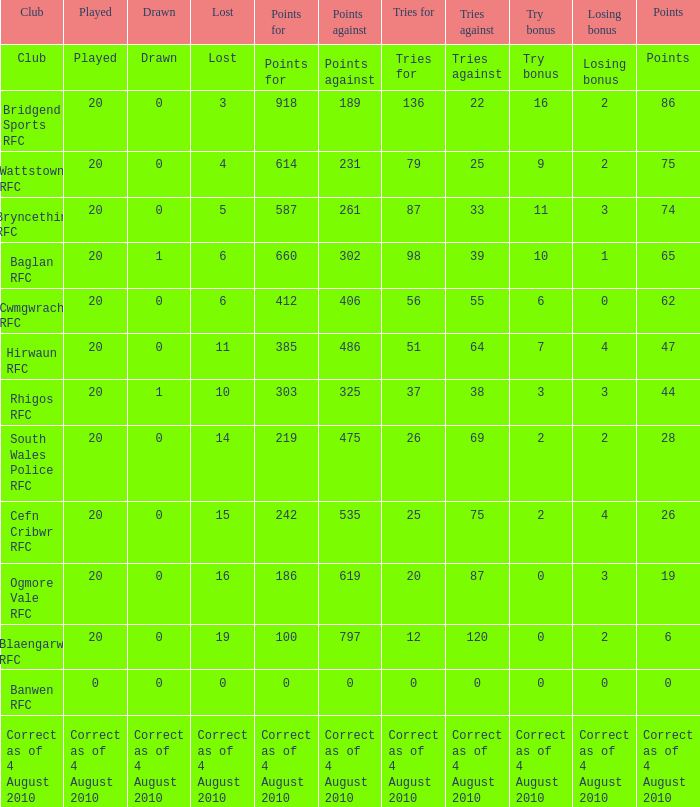Would you be able to parse every entry in this table? {'header': ['Club', 'Played', 'Drawn', 'Lost', 'Points for', 'Points against', 'Tries for', 'Tries against', 'Try bonus', 'Losing bonus', 'Points'], 'rows': [['Club', 'Played', 'Drawn', 'Lost', 'Points for', 'Points against', 'Tries for', 'Tries against', 'Try bonus', 'Losing bonus', 'Points'], ['Bridgend Sports RFC', '20', '0', '3', '918', '189', '136', '22', '16', '2', '86'], ['Wattstown RFC', '20', '0', '4', '614', '231', '79', '25', '9', '2', '75'], ['Bryncethin RFC', '20', '0', '5', '587', '261', '87', '33', '11', '3', '74'], ['Baglan RFC', '20', '1', '6', '660', '302', '98', '39', '10', '1', '65'], ['Cwmgwrach RFC', '20', '0', '6', '412', '406', '56', '55', '6', '0', '62'], ['Hirwaun RFC', '20', '0', '11', '385', '486', '51', '64', '7', '4', '47'], ['Rhigos RFC', '20', '1', '10', '303', '325', '37', '38', '3', '3', '44'], ['South Wales Police RFC', '20', '0', '14', '219', '475', '26', '69', '2', '2', '28'], ['Cefn Cribwr RFC', '20', '0', '15', '242', '535', '25', '75', '2', '4', '26'], ['Ogmore Vale RFC', '20', '0', '16', '186', '619', '20', '87', '0', '3', '19'], ['Blaengarw RFC', '20', '0', '19', '100', '797', '12', '120', '0', '2', '6'], ['Banwen RFC', '0', '0', '0', '0', '0', '0', '0', '0', '0', '0'], ['Correct as of 4 August 2010', 'Correct as of 4 August 2010', 'Correct as of 4 August 2010', 'Correct as of 4 August 2010', 'Correct as of 4 August 2010', 'Correct as of 4 August 2010', 'Correct as of 4 August 2010', 'Correct as of 4 August 2010', 'Correct as of 4 August 2010', 'Correct as of 4 August 2010', 'Correct as of 4 August 2010']]} What are the counterpoints when drawn is represented? Points against. 